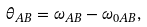Convert formula to latex. <formula><loc_0><loc_0><loc_500><loc_500>\theta _ { A B } = \omega _ { A B } - \omega _ { 0 A B } ,</formula> 